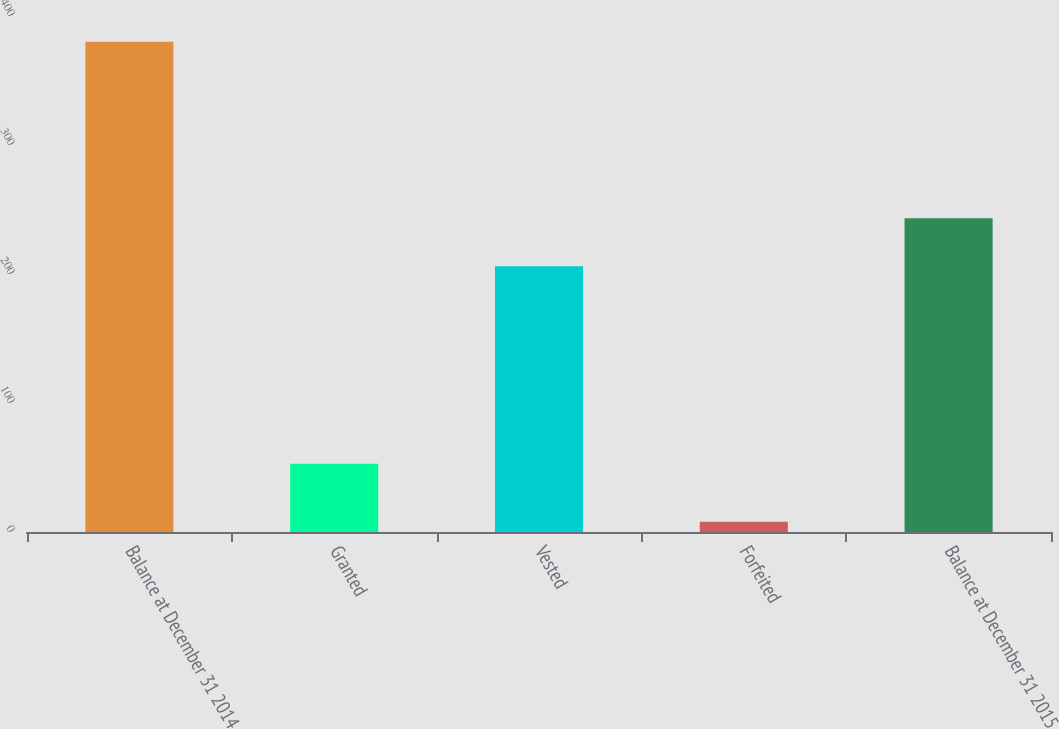<chart> <loc_0><loc_0><loc_500><loc_500><bar_chart><fcel>Balance at December 31 2014<fcel>Granted<fcel>Vested<fcel>Forfeited<fcel>Balance at December 31 2015<nl><fcel>380<fcel>53<fcel>206<fcel>8<fcel>243.2<nl></chart> 